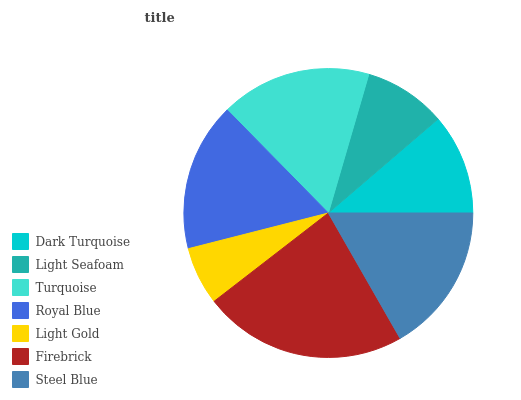Is Light Gold the minimum?
Answer yes or no. Yes. Is Firebrick the maximum?
Answer yes or no. Yes. Is Light Seafoam the minimum?
Answer yes or no. No. Is Light Seafoam the maximum?
Answer yes or no. No. Is Dark Turquoise greater than Light Seafoam?
Answer yes or no. Yes. Is Light Seafoam less than Dark Turquoise?
Answer yes or no. Yes. Is Light Seafoam greater than Dark Turquoise?
Answer yes or no. No. Is Dark Turquoise less than Light Seafoam?
Answer yes or no. No. Is Royal Blue the high median?
Answer yes or no. Yes. Is Royal Blue the low median?
Answer yes or no. Yes. Is Steel Blue the high median?
Answer yes or no. No. Is Steel Blue the low median?
Answer yes or no. No. 